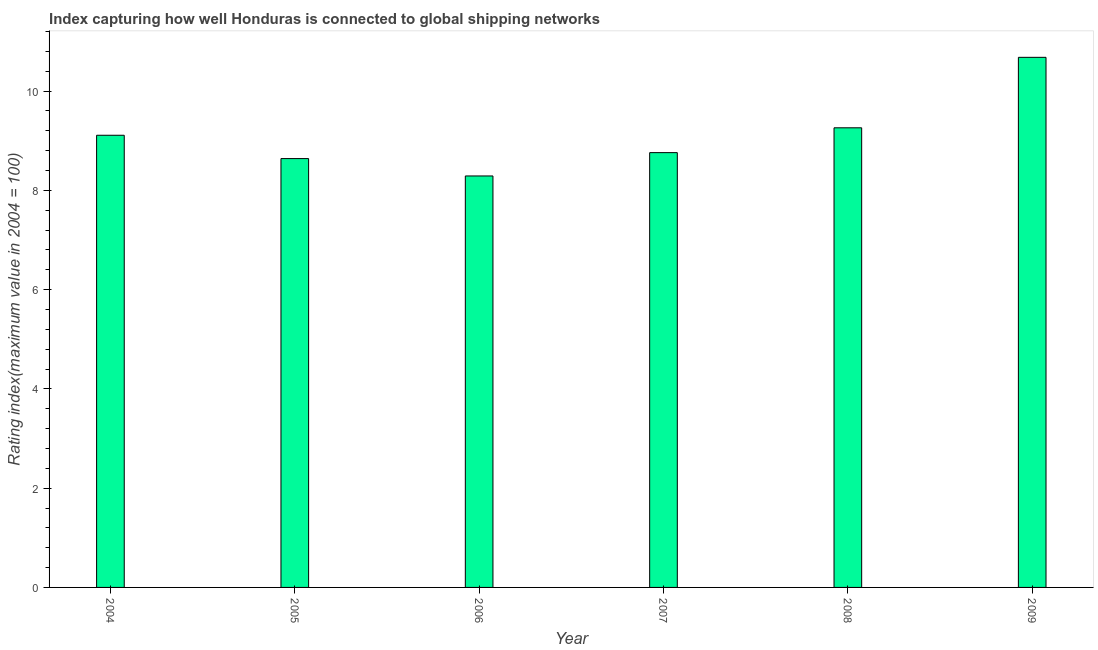Does the graph contain grids?
Your answer should be very brief. No. What is the title of the graph?
Provide a short and direct response. Index capturing how well Honduras is connected to global shipping networks. What is the label or title of the Y-axis?
Provide a short and direct response. Rating index(maximum value in 2004 = 100). What is the liner shipping connectivity index in 2005?
Your response must be concise. 8.64. Across all years, what is the maximum liner shipping connectivity index?
Your answer should be compact. 10.68. Across all years, what is the minimum liner shipping connectivity index?
Ensure brevity in your answer.  8.29. In which year was the liner shipping connectivity index maximum?
Your answer should be very brief. 2009. In which year was the liner shipping connectivity index minimum?
Your answer should be compact. 2006. What is the sum of the liner shipping connectivity index?
Give a very brief answer. 54.74. What is the average liner shipping connectivity index per year?
Your answer should be compact. 9.12. What is the median liner shipping connectivity index?
Make the answer very short. 8.93. In how many years, is the liner shipping connectivity index greater than 5.6 ?
Provide a short and direct response. 6. Do a majority of the years between 2008 and 2004 (inclusive) have liner shipping connectivity index greater than 5.6 ?
Make the answer very short. Yes. What is the ratio of the liner shipping connectivity index in 2004 to that in 2009?
Give a very brief answer. 0.85. Is the difference between the liner shipping connectivity index in 2005 and 2006 greater than the difference between any two years?
Offer a terse response. No. What is the difference between the highest and the second highest liner shipping connectivity index?
Keep it short and to the point. 1.42. What is the difference between the highest and the lowest liner shipping connectivity index?
Your answer should be compact. 2.39. In how many years, is the liner shipping connectivity index greater than the average liner shipping connectivity index taken over all years?
Provide a short and direct response. 2. Are all the bars in the graph horizontal?
Your answer should be very brief. No. What is the difference between two consecutive major ticks on the Y-axis?
Your answer should be very brief. 2. What is the Rating index(maximum value in 2004 = 100) of 2004?
Ensure brevity in your answer.  9.11. What is the Rating index(maximum value in 2004 = 100) in 2005?
Offer a terse response. 8.64. What is the Rating index(maximum value in 2004 = 100) of 2006?
Offer a terse response. 8.29. What is the Rating index(maximum value in 2004 = 100) of 2007?
Offer a terse response. 8.76. What is the Rating index(maximum value in 2004 = 100) in 2008?
Make the answer very short. 9.26. What is the Rating index(maximum value in 2004 = 100) of 2009?
Keep it short and to the point. 10.68. What is the difference between the Rating index(maximum value in 2004 = 100) in 2004 and 2005?
Offer a terse response. 0.47. What is the difference between the Rating index(maximum value in 2004 = 100) in 2004 and 2006?
Your answer should be compact. 0.82. What is the difference between the Rating index(maximum value in 2004 = 100) in 2004 and 2007?
Make the answer very short. 0.35. What is the difference between the Rating index(maximum value in 2004 = 100) in 2004 and 2009?
Your response must be concise. -1.57. What is the difference between the Rating index(maximum value in 2004 = 100) in 2005 and 2007?
Your response must be concise. -0.12. What is the difference between the Rating index(maximum value in 2004 = 100) in 2005 and 2008?
Your response must be concise. -0.62. What is the difference between the Rating index(maximum value in 2004 = 100) in 2005 and 2009?
Your answer should be compact. -2.04. What is the difference between the Rating index(maximum value in 2004 = 100) in 2006 and 2007?
Offer a terse response. -0.47. What is the difference between the Rating index(maximum value in 2004 = 100) in 2006 and 2008?
Offer a very short reply. -0.97. What is the difference between the Rating index(maximum value in 2004 = 100) in 2006 and 2009?
Ensure brevity in your answer.  -2.39. What is the difference between the Rating index(maximum value in 2004 = 100) in 2007 and 2009?
Your response must be concise. -1.92. What is the difference between the Rating index(maximum value in 2004 = 100) in 2008 and 2009?
Your answer should be very brief. -1.42. What is the ratio of the Rating index(maximum value in 2004 = 100) in 2004 to that in 2005?
Provide a succinct answer. 1.05. What is the ratio of the Rating index(maximum value in 2004 = 100) in 2004 to that in 2006?
Make the answer very short. 1.1. What is the ratio of the Rating index(maximum value in 2004 = 100) in 2004 to that in 2009?
Offer a very short reply. 0.85. What is the ratio of the Rating index(maximum value in 2004 = 100) in 2005 to that in 2006?
Provide a short and direct response. 1.04. What is the ratio of the Rating index(maximum value in 2004 = 100) in 2005 to that in 2007?
Keep it short and to the point. 0.99. What is the ratio of the Rating index(maximum value in 2004 = 100) in 2005 to that in 2008?
Offer a very short reply. 0.93. What is the ratio of the Rating index(maximum value in 2004 = 100) in 2005 to that in 2009?
Give a very brief answer. 0.81. What is the ratio of the Rating index(maximum value in 2004 = 100) in 2006 to that in 2007?
Ensure brevity in your answer.  0.95. What is the ratio of the Rating index(maximum value in 2004 = 100) in 2006 to that in 2008?
Offer a terse response. 0.9. What is the ratio of the Rating index(maximum value in 2004 = 100) in 2006 to that in 2009?
Provide a short and direct response. 0.78. What is the ratio of the Rating index(maximum value in 2004 = 100) in 2007 to that in 2008?
Your answer should be very brief. 0.95. What is the ratio of the Rating index(maximum value in 2004 = 100) in 2007 to that in 2009?
Offer a very short reply. 0.82. What is the ratio of the Rating index(maximum value in 2004 = 100) in 2008 to that in 2009?
Offer a very short reply. 0.87. 